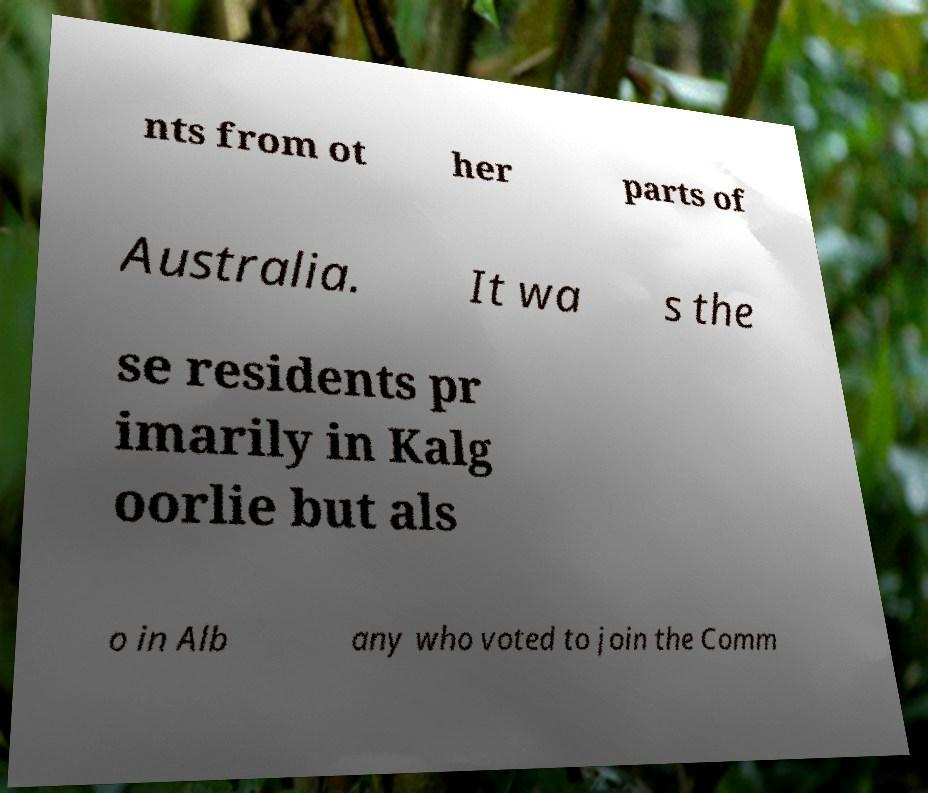For documentation purposes, I need the text within this image transcribed. Could you provide that? nts from ot her parts of Australia. It wa s the se residents pr imarily in Kalg oorlie but als o in Alb any who voted to join the Comm 